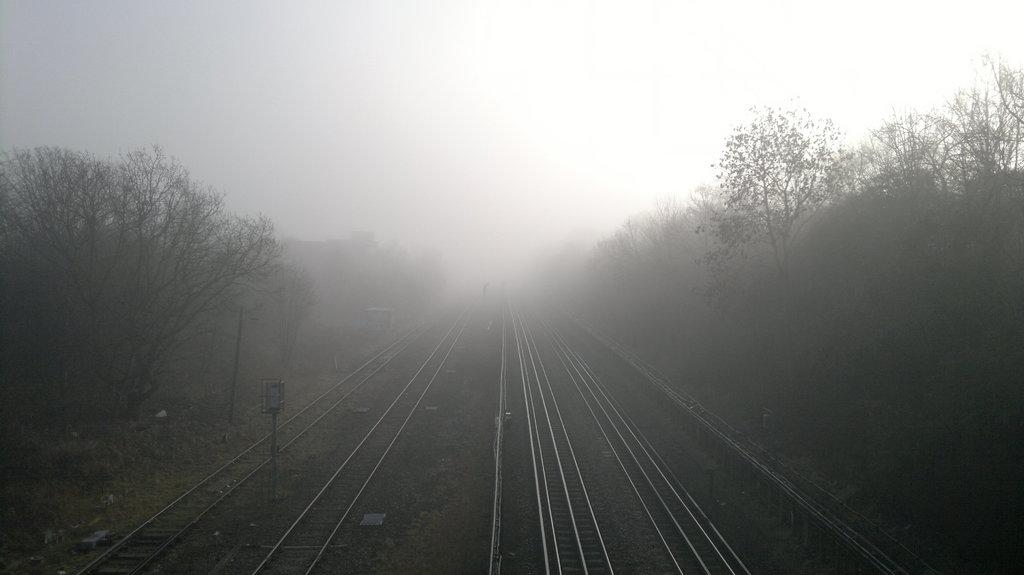What is the main feature of the image? There is a track in the image. What can be seen alongside the track? There are many trees to the side of the track. What is visible in the background of the image? The sky is visible in the background of the image. Where is the pot located in the image? There is no pot present in the image. What part of the track is being used in the image? The entire track is visible in the image, but there is no indication of which part is being used. 